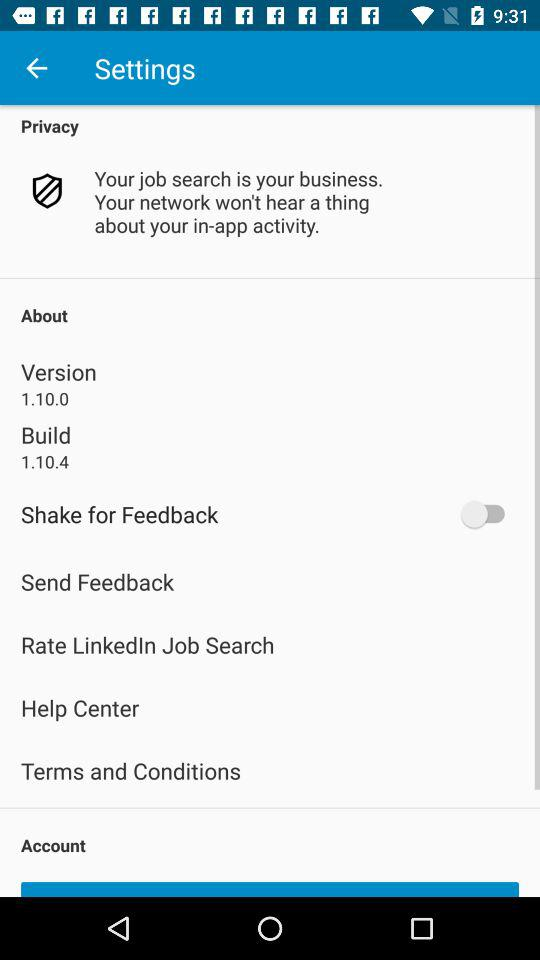What is the given build number? The given build number is 1.10.4. 